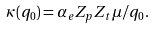<formula> <loc_0><loc_0><loc_500><loc_500>\kappa ( q _ { 0 } ) = \alpha _ { e } Z _ { p } Z _ { t } \mu / q _ { 0 } .</formula> 